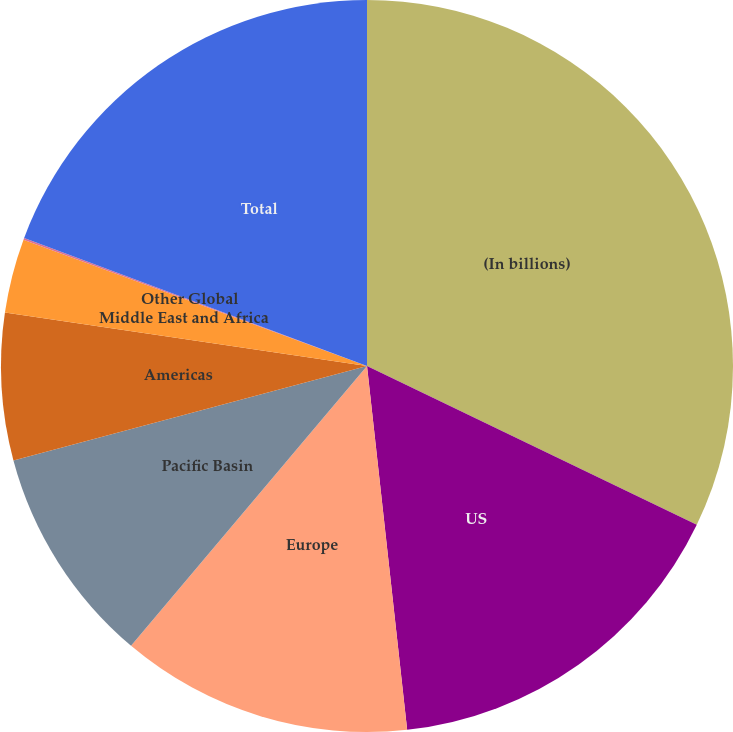Convert chart. <chart><loc_0><loc_0><loc_500><loc_500><pie_chart><fcel>(In billions)<fcel>US<fcel>Europe<fcel>Pacific Basin<fcel>Americas<fcel>Middle East and Africa<fcel>Other Global<fcel>Total<nl><fcel>32.14%<fcel>16.11%<fcel>12.9%<fcel>9.69%<fcel>6.49%<fcel>3.28%<fcel>0.08%<fcel>19.31%<nl></chart> 